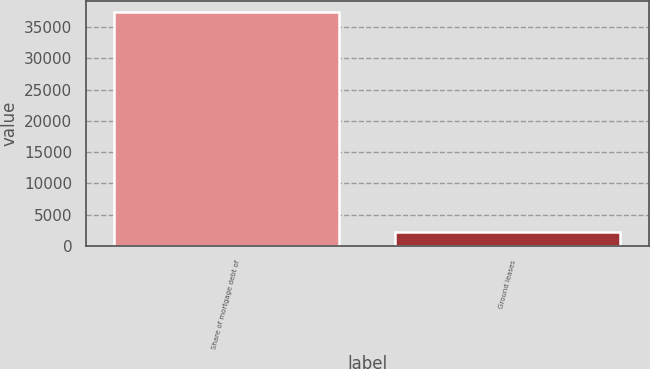Convert chart. <chart><loc_0><loc_0><loc_500><loc_500><bar_chart><fcel>Share of mortgage debt of<fcel>Ground leases<nl><fcel>37387<fcel>2229<nl></chart> 